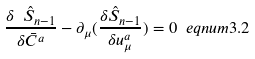Convert formula to latex. <formula><loc_0><loc_0><loc_500><loc_500>\frac { \delta \ \hat { S } _ { n - 1 } } { \delta \bar { C } ^ { a } } - \partial _ { \mu } ( \frac { \delta \hat { S } _ { n - 1 } } { \delta u _ { \mu } ^ { a } } ) = 0 \ e q n u m { 3 . 2 }</formula> 